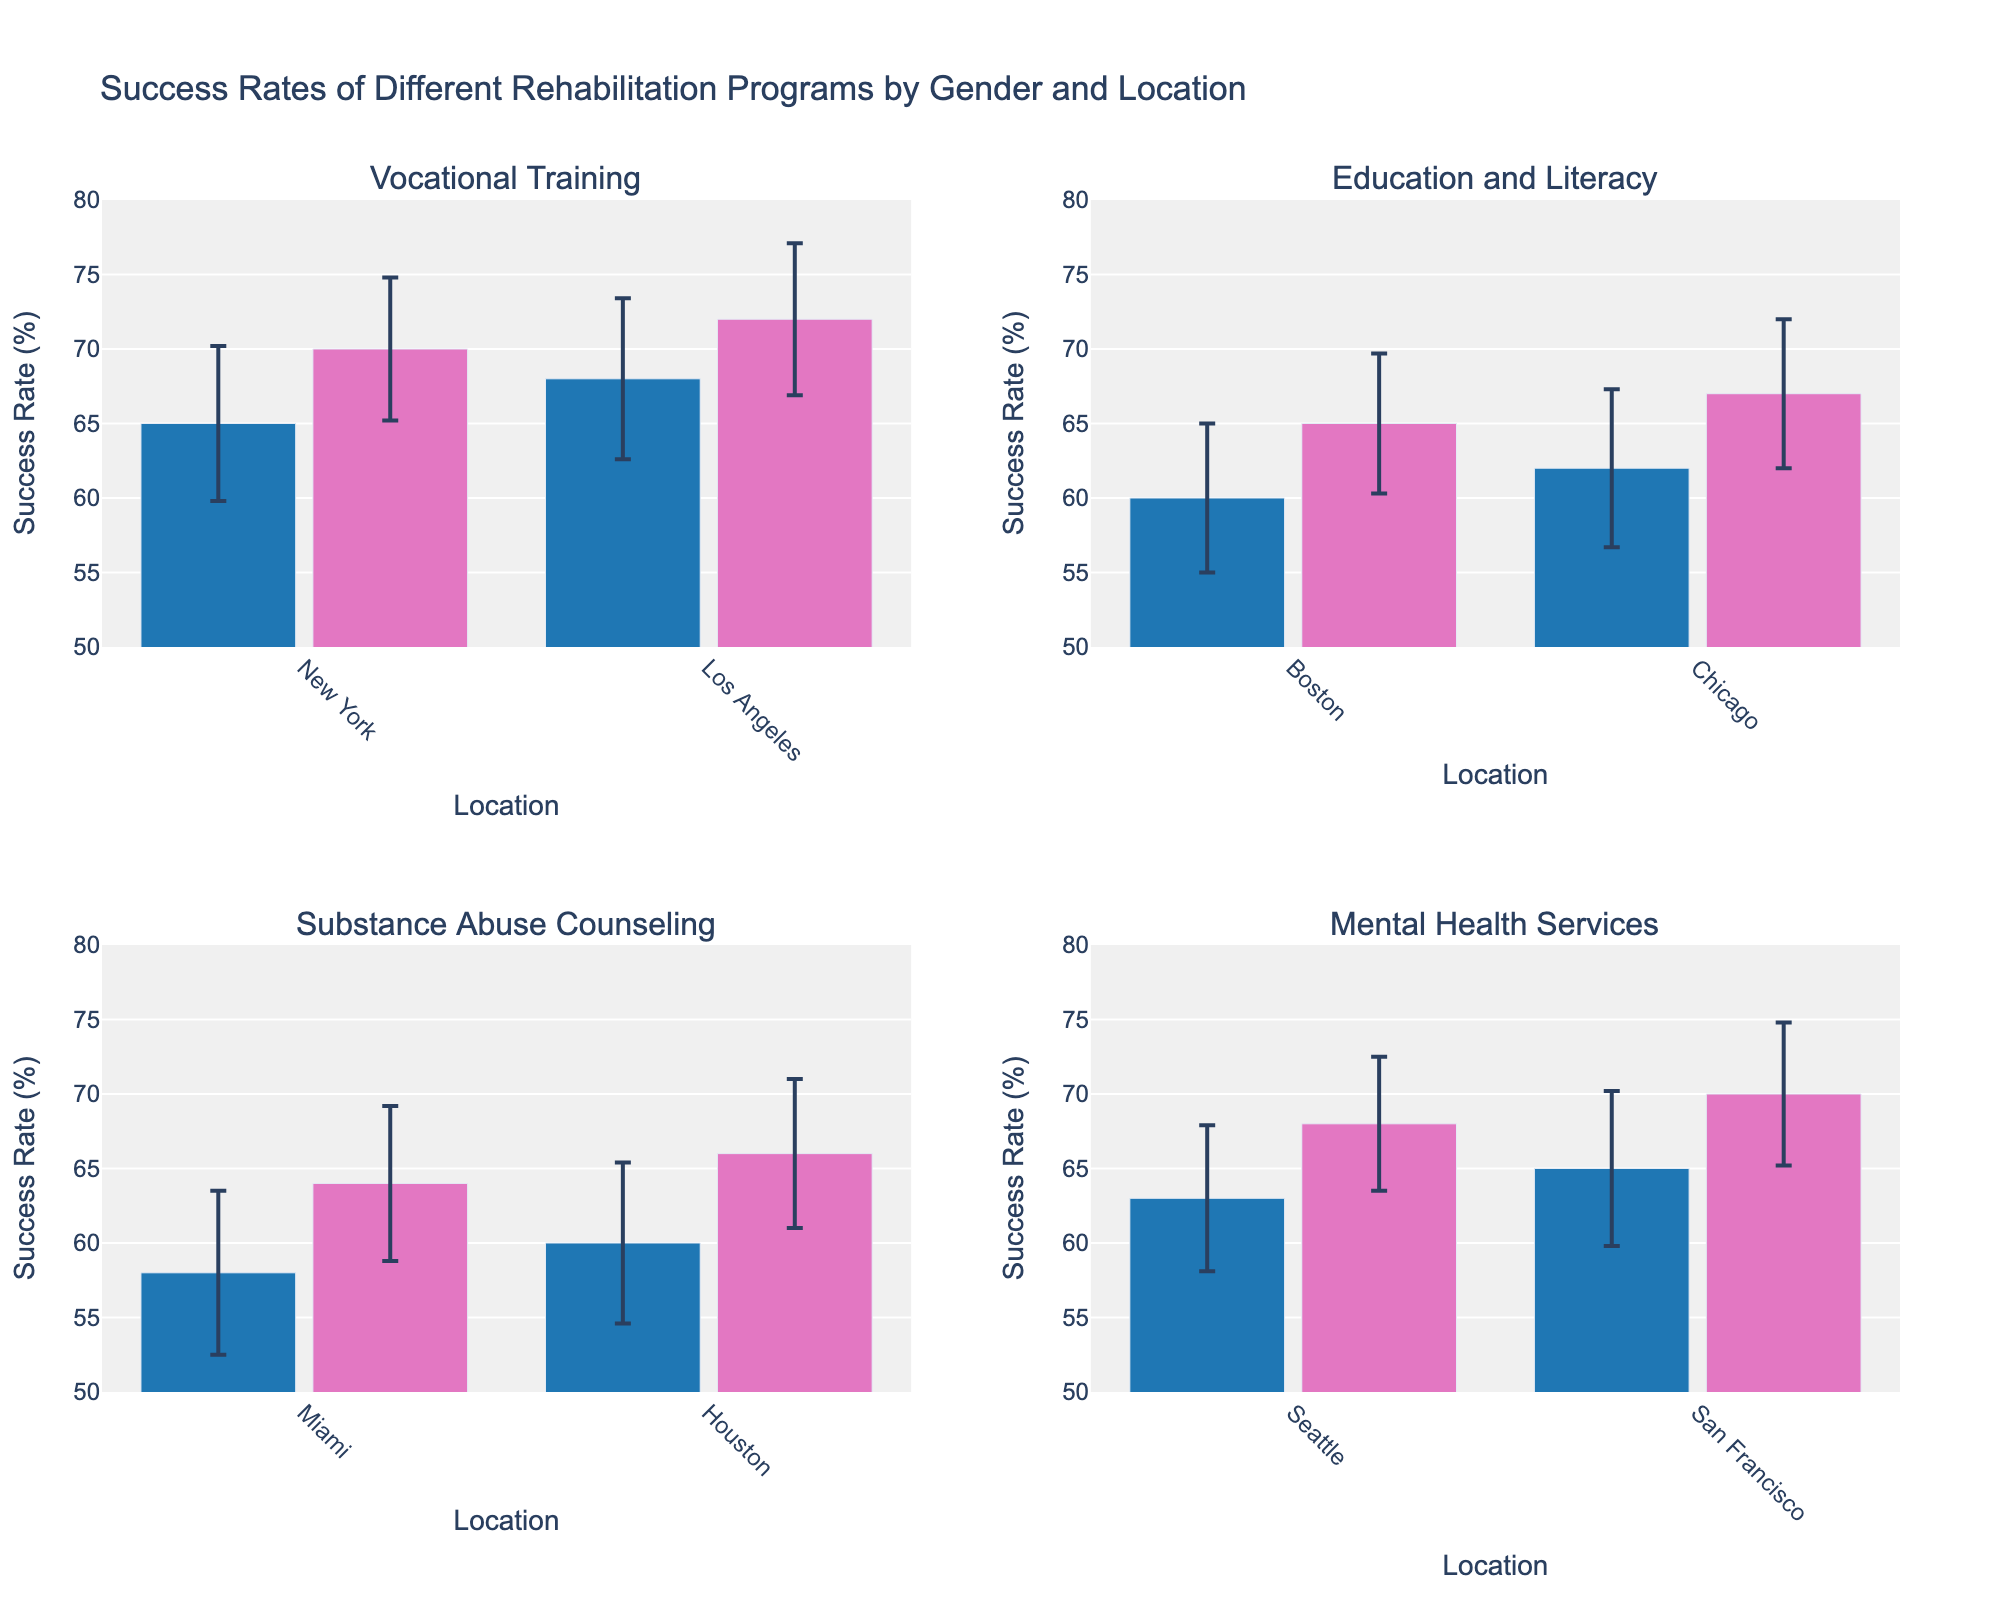What's the title of the figure? The title is typically placed at the top of the figure. Here, it reads: "Success Rates of Different Rehabilitation Programs by Gender and Location"
Answer: Success Rates of Different Rehabilitation Programs by Gender and Location What is the average success rate for Vocational Training across all locations for females? For females in Vocational Training, the success rates are 70 (New York) and 72 (Los Angeles). Calculate the average: (70 + 72) / 2 = 71
Answer: 71 Which location has the highest success rate for males in Substance Abuse Counseling? Check the success rates for males in Substance Abuse Counseling in both locations: Miami (58), Houston (60). Houston has the highest rate, 60.
Answer: Houston Are the success rates for Mental Health Services higher for females than males in San Francisco? In San Francisco, the success rates are 65 for males and 70 for females. Compare 70 and 65: 70 is higher.
Answer: Yes What's the difference in the success rates between males and females for Education and Literacy in Boston? In Boston, the success rates are 60 for males and 65 for females. The difference is 65 - 60 = 5
Answer: 5 Which rehabilitation program has the smallest variation in success rates between genders in the same location? Calculate the difference in success rates for each program in each location and find the smallest difference:
- Vocational Training (New York): 70 - 65 = 5 
- Vocational Training (Los Angeles): 72 - 68 = 4
- Education and Literacy (Boston): 65 - 60 = 5
- Education and Literacy (Chicago): 67 - 62 = 5
- Substance Abuse Counseling (Miami): 64 - 58 = 6
- Substance Abuse Counseling (Houston): 66 - 60 = 6
- Mental Health Services (Seattle): 68 - 63 = 5
- Mental Health Services (San Francisco): 70 - 65 = 5
The smallest difference is 4 for Vocational Training in Los Angeles.
Answer: Vocational Training in Los Angeles Considering error bars, which program-location-gender combination shows the lowest degree of uncertainty? The uncertainty is represented by the standard deviation in the error bars. Find the smallest standard deviation:
- Vocational Training (New York, Female): 4.8
- Vocational Training (Los Angeles, Female): 5.1
- Education and Literacy (Boston, Female): 4.7
- Education and Literacy (Chicago, Female): 5.0
- Substance Abuse Counseling (Miami, Female): 5.2
- Substance Abuse Counseling (Houston, Female): 5.0
- Mental Health Services (Seattle, Female): 4.5
- Mental Health Services (San Francisco, Female): 4.8
The lowest degree of uncertainty is for Mental Health Services (Seattle, Female) with a standard deviation of 4.5.
Answer: Mental Health Services in Seattle for Females What is the range of success rates for Substance Abuse Counseling across both genders and all locations? For Substance Abuse Counseling, the success rates range from 58 to 66.
Answer: [58, 66] How do the success rates of Mental Health Services in Seattle compare between genders? For Mental Health Services in Seattle, the success rates are 63 for males and 68 for females. Compare the two values: 68 is higher than 63.
Answer: Females have higher success rates 